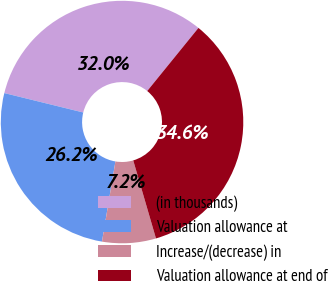Convert chart to OTSL. <chart><loc_0><loc_0><loc_500><loc_500><pie_chart><fcel>(in thousands)<fcel>Valuation allowance at<fcel>Increase/(decrease) in<fcel>Valuation allowance at end of<nl><fcel>32.01%<fcel>26.19%<fcel>7.16%<fcel>34.63%<nl></chart> 